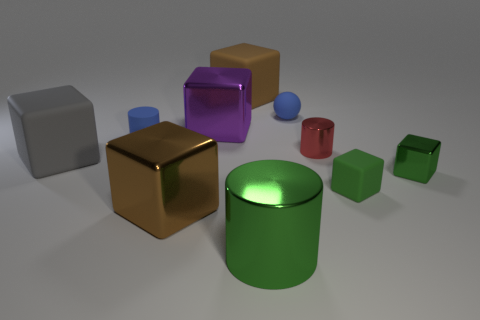Do the colors of these objects reflect any particular pattern or theme? The objects display a variety of colors with no immediately discernible pattern or theme. There are examples of primary colors like red and blue, as well as secondary and other hues such as green, purple, and gold. This suggests a deliberate choice to showcase diversity in color, possibly for a visual assessment or for an artistic composition aimed at demonstrating contrast and variety. If this image were part of a learning module for children, what kind of questions would you ask to engage them? If this were part of a learning module for children, questions that engage their observational skills and critical thinking might include: 'Which is the largest object and why do you think it's made that size?' or 'Can you count the objects that are the same shape as a dice?' Such questions help to develop their understanding of shapes, sizes, and reasoning skills. 